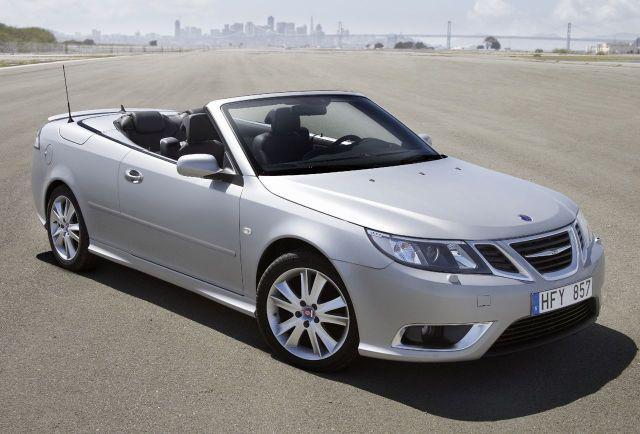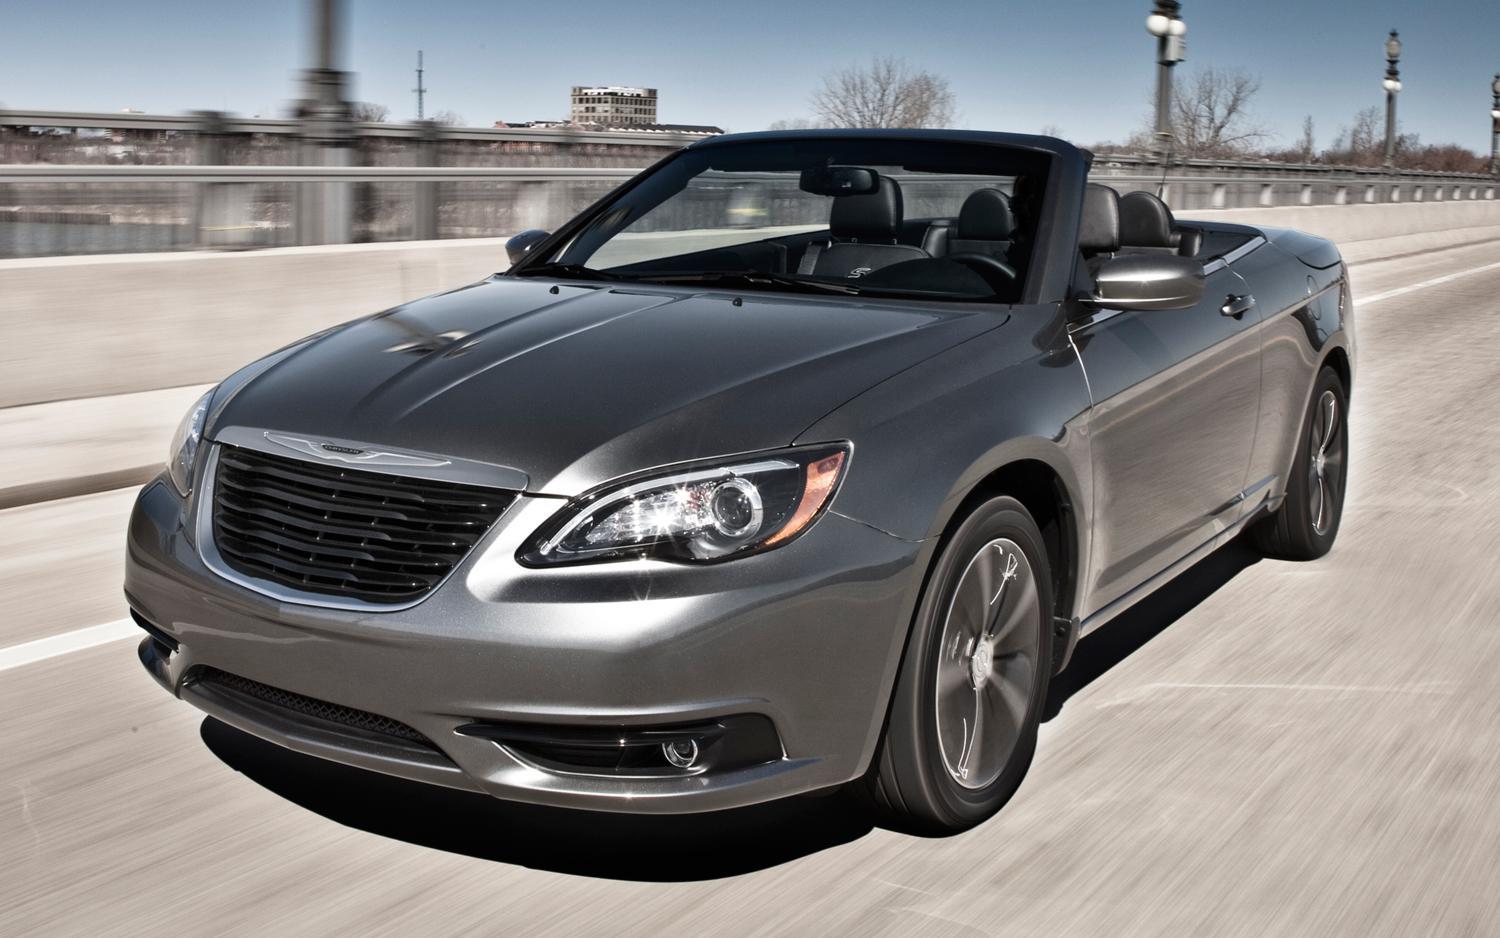The first image is the image on the left, the second image is the image on the right. Analyze the images presented: Is the assertion "Two convertibles with black interior are facing foreward in different directions, both with chrome wheels, but only one with a license plate." valid? Answer yes or no. Yes. 